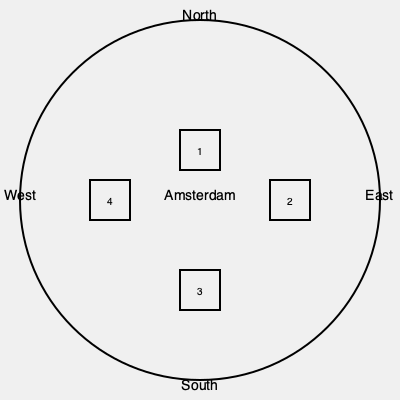Arrange the following Amsterdam landmarks in their correct spatial positions on the map: A) Anne Frank House, B) Royal Palace, C) Rijksmuseum, D) NEMO Science Museum. Match each landmark to the numbered position (1-4) on the map. To arrange the Amsterdam landmarks correctly, we need to consider their relative positions in the city:

1. The Royal Palace is located in the city center, slightly north of the geographical center. This corresponds to position 1 on the map.

2. The NEMO Science Museum is situated to the east of the city center, near the waterfront. This aligns with position 2 on the map.

3. The Rijksmuseum is located south of the city center, in the Museum Quarter. This matches position 3 on the map.

4. The Anne Frank House is situated to the west of the city center, in the Jordaan neighborhood. This corresponds to position 4 on the map.

Therefore, the correct arrangement is:
1 - B) Royal Palace
2 - D) NEMO Science Museum
3 - C) Rijksmuseum
4 - A) Anne Frank House
Answer: 1-B, 2-D, 3-C, 4-A 